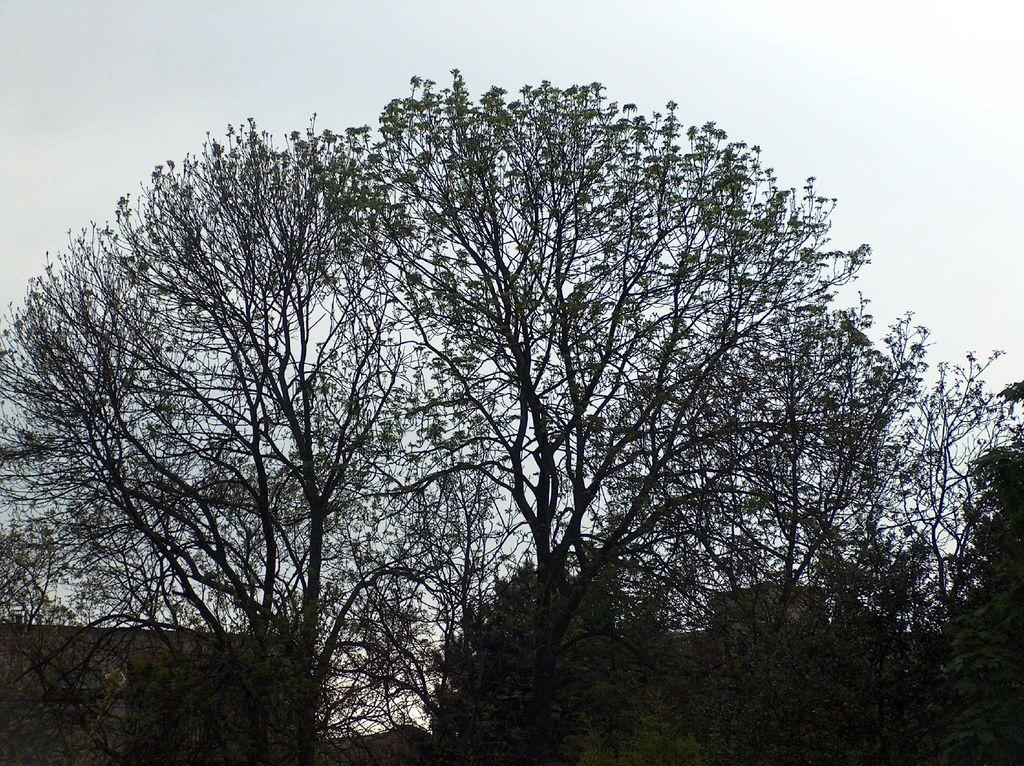What type of vegetation can be seen in the image? There are trees in the image. What structures are visible behind the trees? There are buildings visible behind the trees. What is visible at the top of the image? The sky is visible at the top of the image. How many spiders are crawling on the buildings in the image? There are no spiders visible in the image; it only features trees, buildings, and the sky. What type of shock can be seen in the image? There is no shock present in the image. 